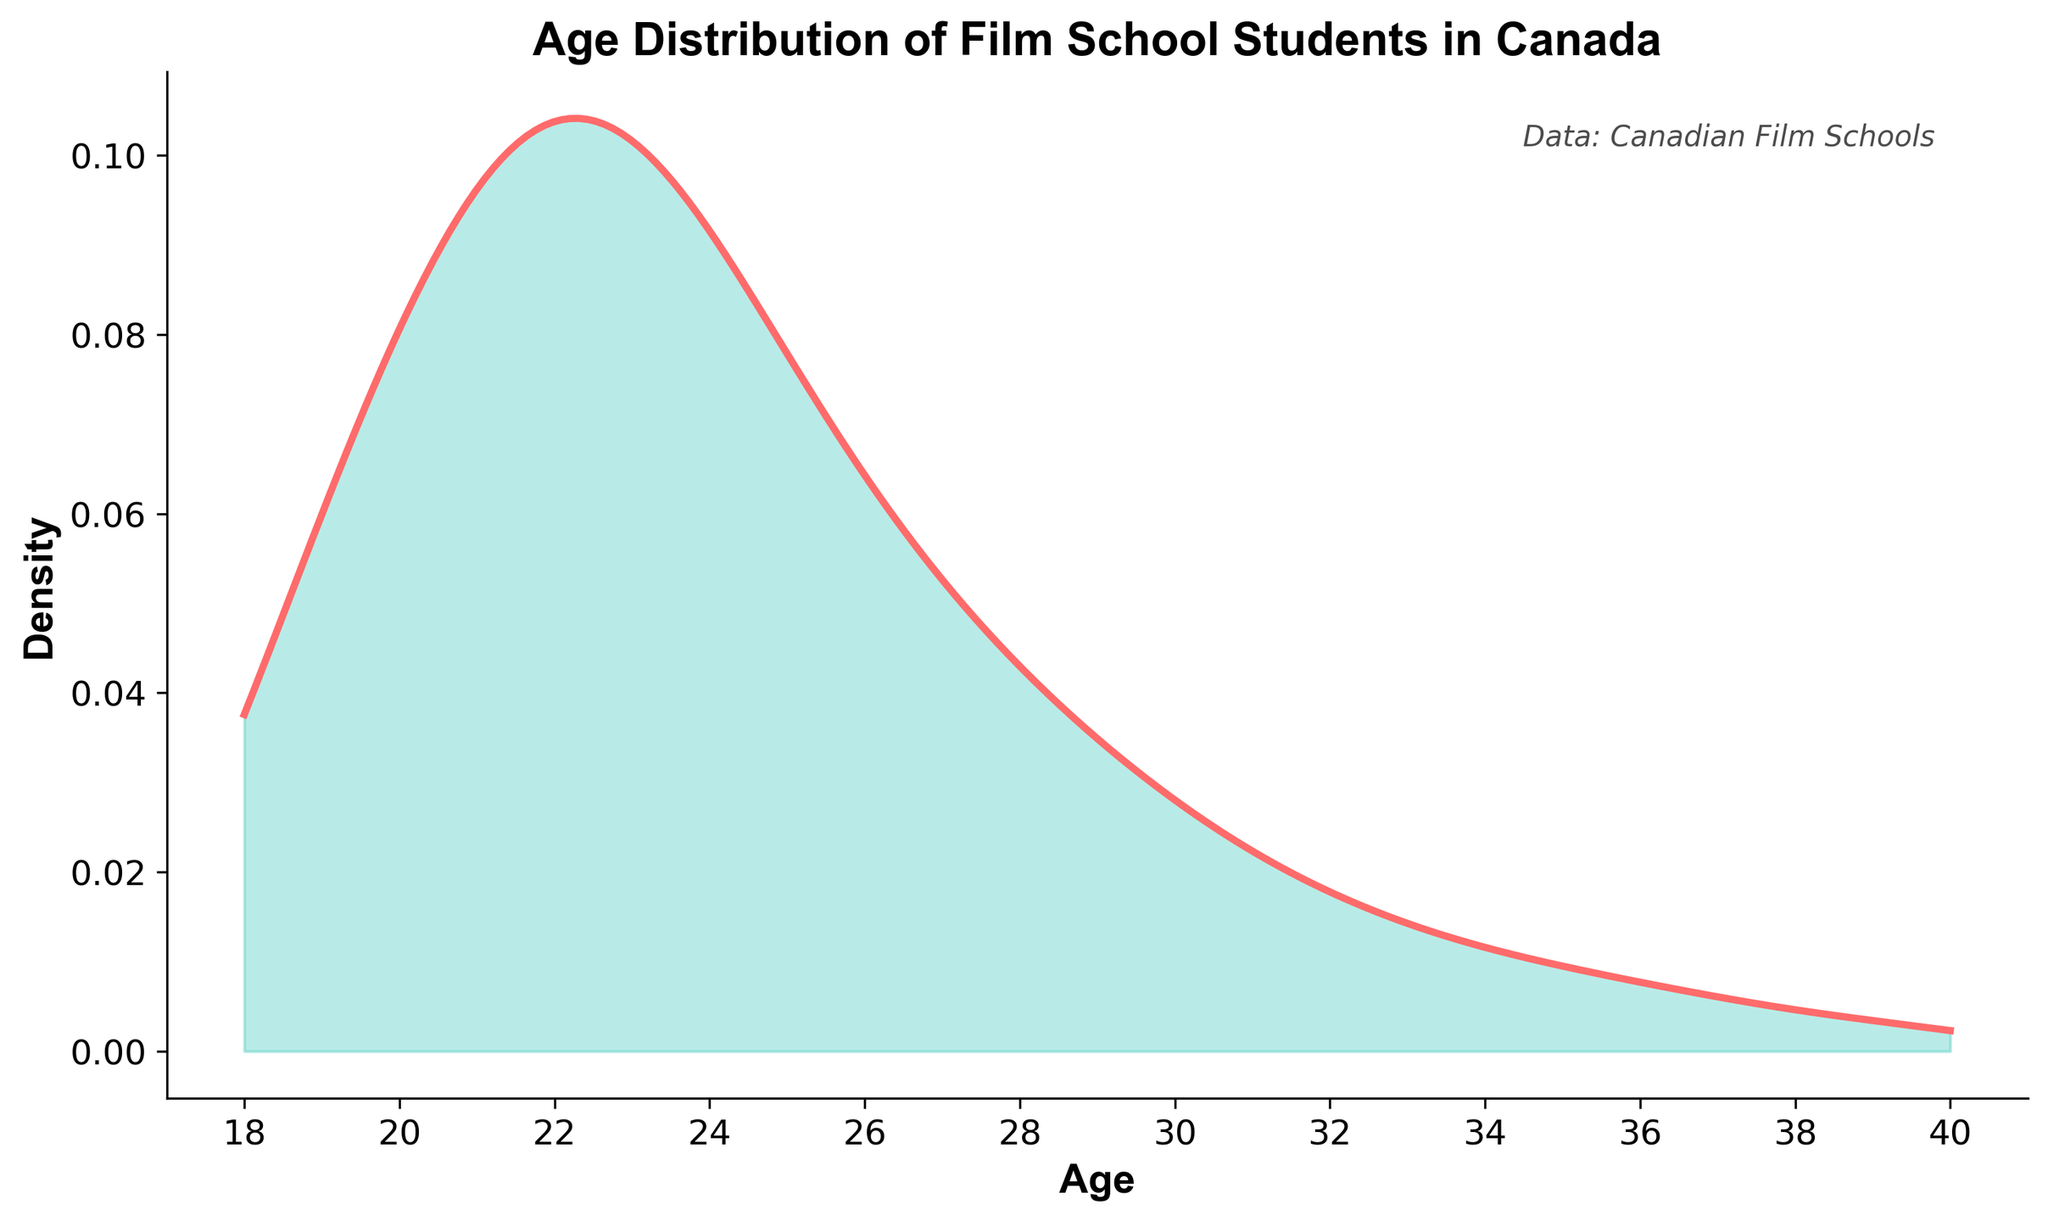What is the title of the figure? The title is usually displayed at the top of the chart, giving a brief summary of what the plot represents.
Answer: Age Distribution of Film School Students in Canada Between which ages is the highest density observed? The highest peak or mode in a density plot indicates where the concentration of data points is greatest.
Answer: 21 to 23 years What does the x-axis represent? The x-axis labels indicate what the horizontal axis measures, which is shown as 'Age'.
Answer: Age Which age group has a density lower than the age group of 23 years? By visual inspection of the density plot, you can compare the height of the curve at different age points relative to age 23.
Answer: Ages lower than 23 years observe lower densities, e.g., 20, 19, and 18 At what age does the density start to noticeably decline? The curve begins to drop off after the peak; in this case, after around age 23.
Answer: Around 25 years What is the shape of the overall density curve? Observing the general layout of the density plot helps to determine if it shows a single peak (unimodal) or multiple peaks (multimodal).
Answer: Unimodal What is the approximate density value at age 30? By locating age 30 on the x-axis and reading the corresponding density value on the y-axis.
Answer: Approximately 0.03 Which age group shows the least density? The age group which corresponds to the lowest point on the density curve.
Answer: 38 to 40 years How many major peaks are visible in the plot? Counting the prominent peaks in the density plot will give the number of major peaks, indicative of the highest densities.
Answer: One major peak How do the densities of 18 and 35-year-olds compare? By locating the densities of ages 18 and 35 on the plot and comparing their height.
Answer: Density at 18 is higher than at 35 